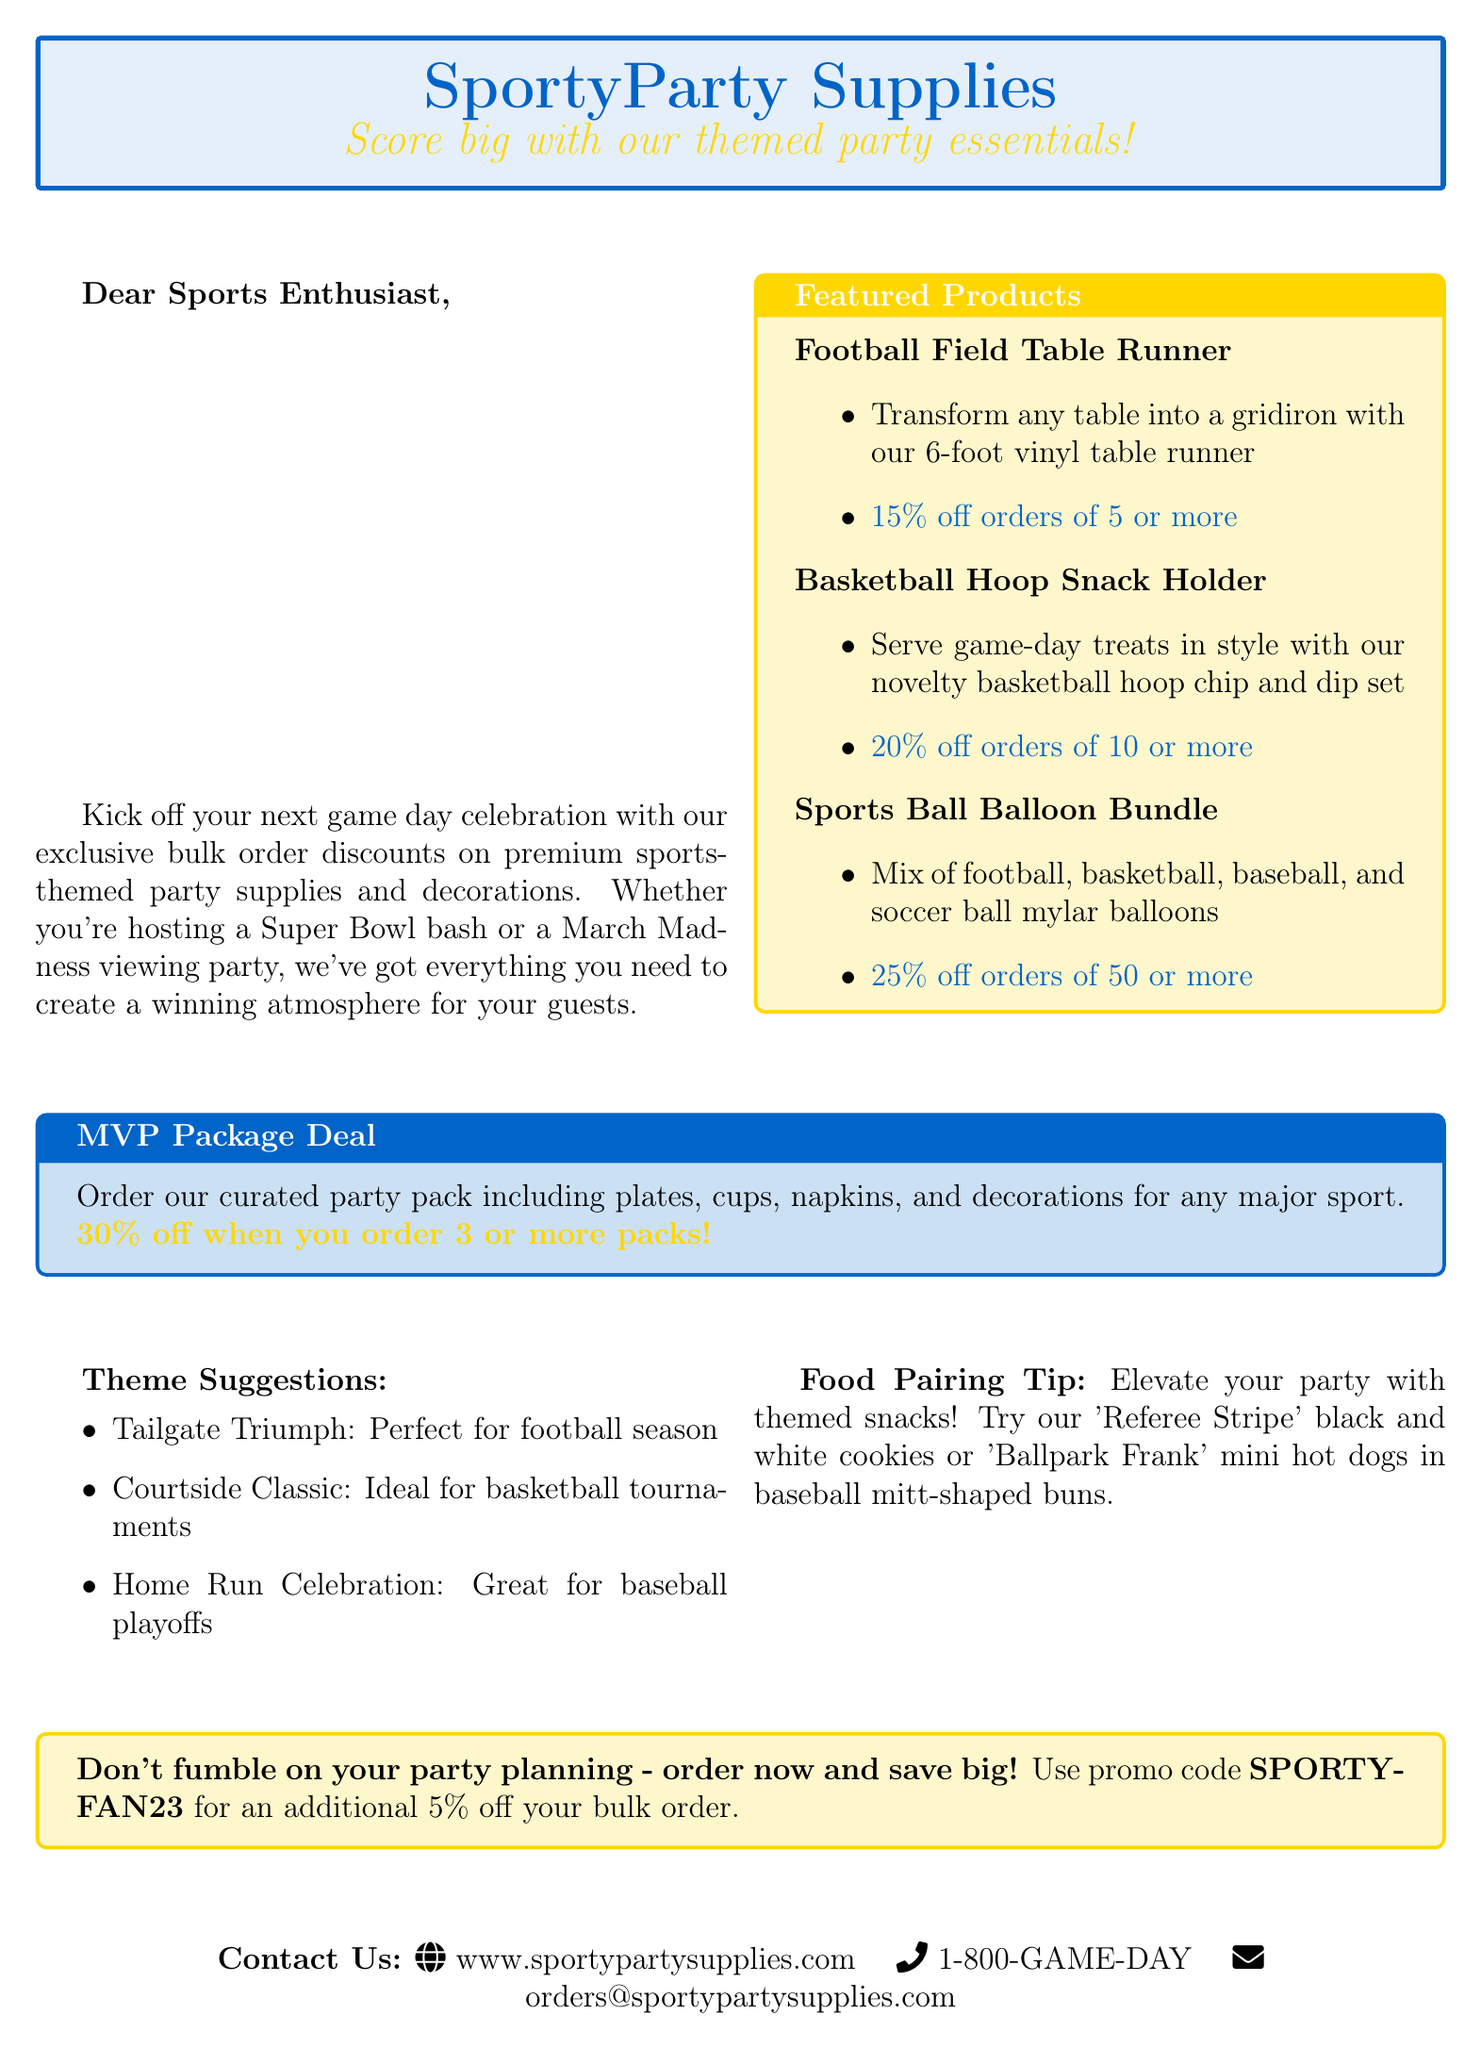What is the company name? The company name is mentioned in the header of the document.
Answer: SportyParty Supplies What discount is offered on the Football Field Table Runner? The discount details for featured products can be found in the featured products section.
Answer: 15% off orders of 5 or more What themed food item is suggested? The food pairing tip provides specific themed snack suggestions.
Answer: Referee Stripe cookies How much is the discount on the MVP Package Deal? The MVP Package Deal states the discount in bold text.
Answer: 30% off when you order 3 or more packs What is the contact email provided? The contact information section includes an email for inquiries.
Answer: orders@sportypartysupplies.com Which sport does the theme "Home Run Celebration" correspond to? The theme suggestions explicitly link themes to corresponding sports.
Answer: Baseball What is the promotional code for an additional discount? The closing statement specifies a promotional code for extra savings.
Answer: SPORTYFAN23 How many Sports Ball Balloon Bundles do you need to qualify for the discount? The discount condition for the Sports Ball Balloon Bundle is provided in the details.
Answer: 50 or more 